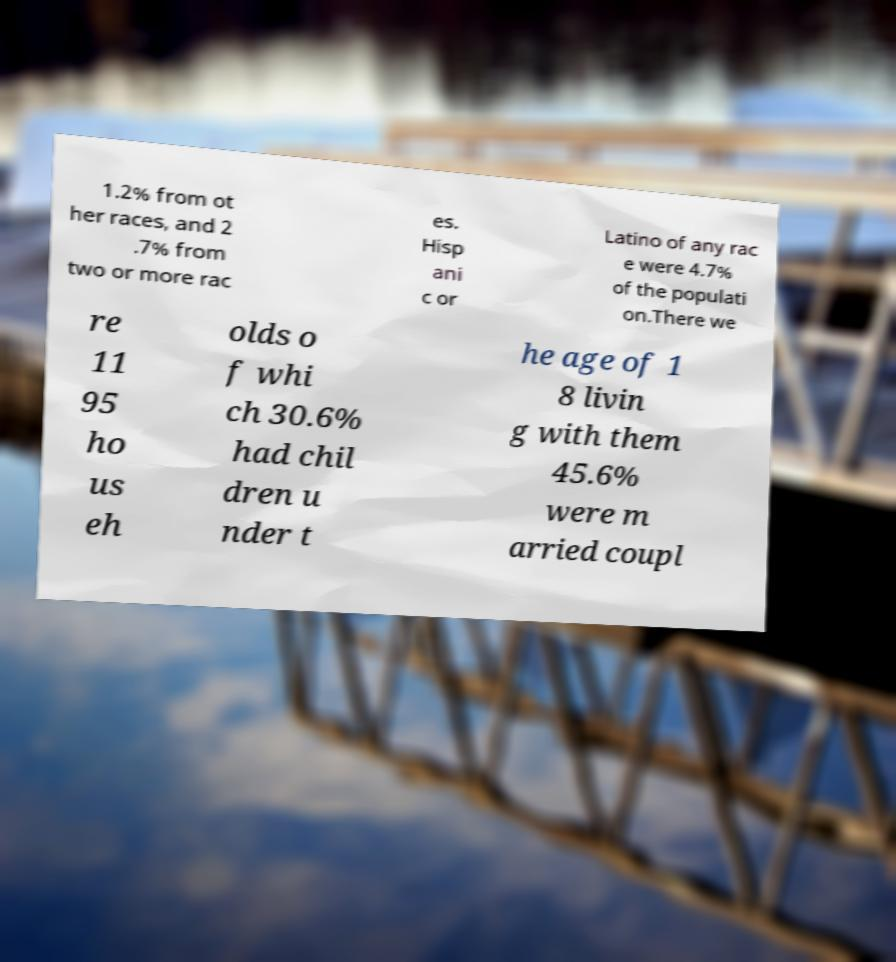Could you assist in decoding the text presented in this image and type it out clearly? 1.2% from ot her races, and 2 .7% from two or more rac es. Hisp ani c or Latino of any rac e were 4.7% of the populati on.There we re 11 95 ho us eh olds o f whi ch 30.6% had chil dren u nder t he age of 1 8 livin g with them 45.6% were m arried coupl 